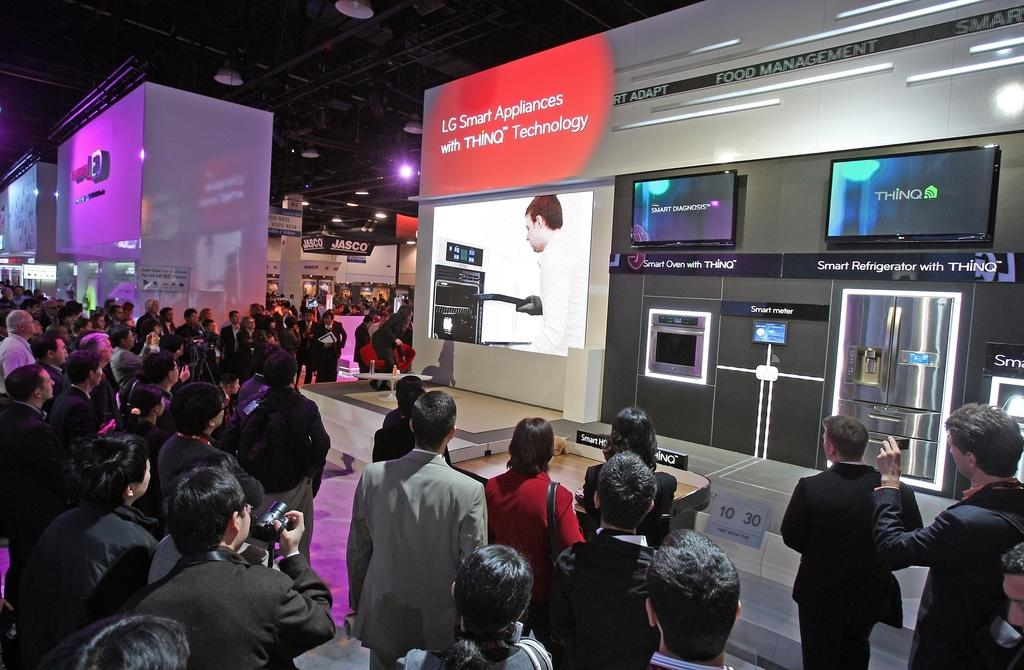What type of establishment is shown in the image? There is a showroom in the image. What kind of products can be seen in the showroom? Electronic items are present in the showroom. What are the people in the image doing? There are people watching the electronic items in the showroom. What architectural features can be seen in the background of the image? There are pillars visible in the background of the image. What type of lighting is present in the showroom? There are lights in the ceiling in the background of the image. What type of drug is being sold in the showroom? There is no mention of any drug being sold in the showroom; it features electronic items. 